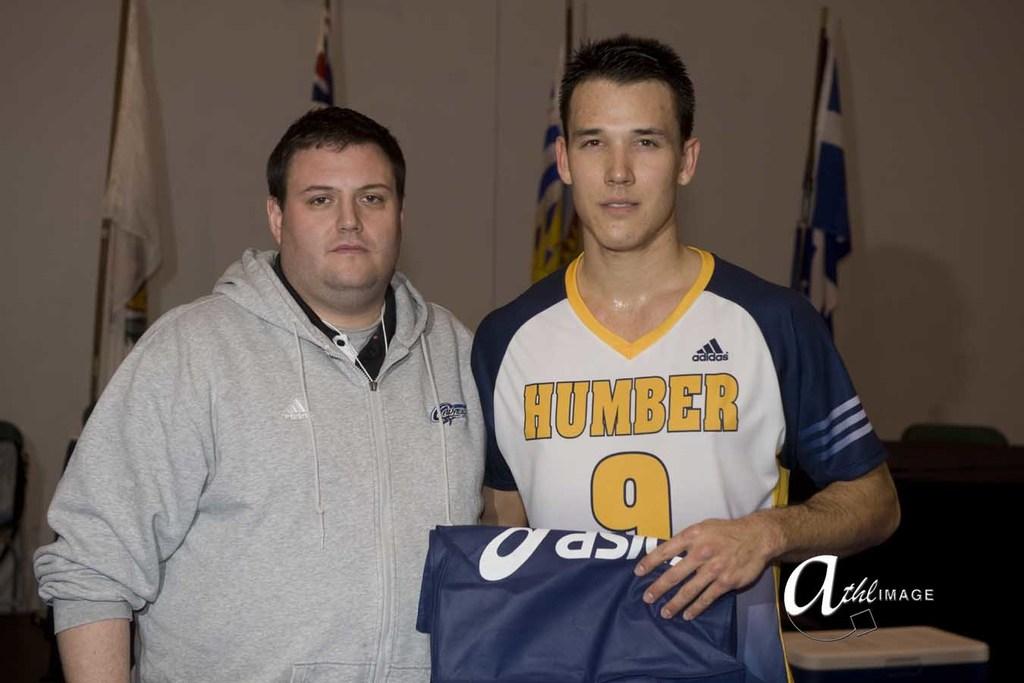What team does the young man play for?
Your response must be concise. Humber. What sportswear company made his shirt?
Your answer should be compact. Adidas. 